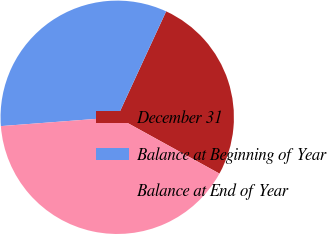<chart> <loc_0><loc_0><loc_500><loc_500><pie_chart><fcel>December 31<fcel>Balance at Beginning of Year<fcel>Balance at End of Year<nl><fcel>26.13%<fcel>33.09%<fcel>40.78%<nl></chart> 